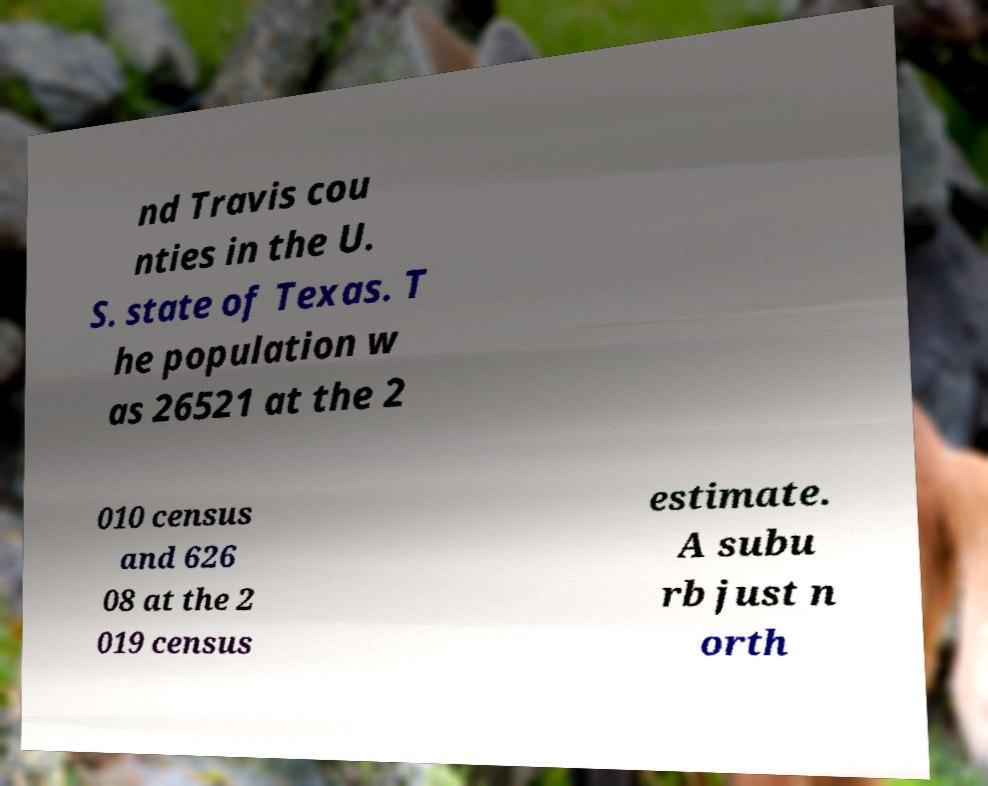Can you accurately transcribe the text from the provided image for me? nd Travis cou nties in the U. S. state of Texas. T he population w as 26521 at the 2 010 census and 626 08 at the 2 019 census estimate. A subu rb just n orth 